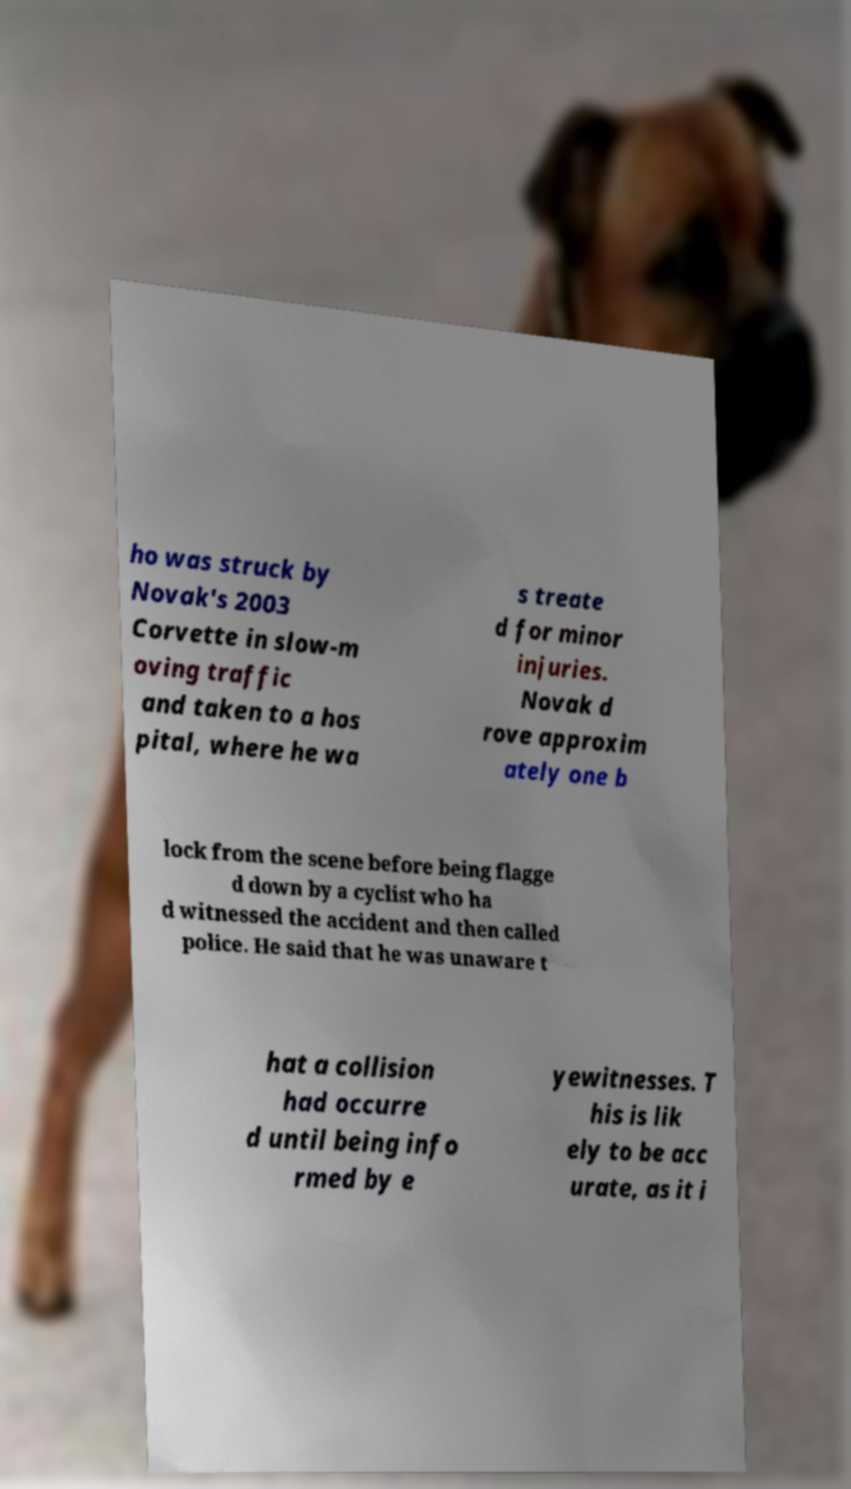Could you assist in decoding the text presented in this image and type it out clearly? ho was struck by Novak's 2003 Corvette in slow-m oving traffic and taken to a hos pital, where he wa s treate d for minor injuries. Novak d rove approxim ately one b lock from the scene before being flagge d down by a cyclist who ha d witnessed the accident and then called police. He said that he was unaware t hat a collision had occurre d until being info rmed by e yewitnesses. T his is lik ely to be acc urate, as it i 